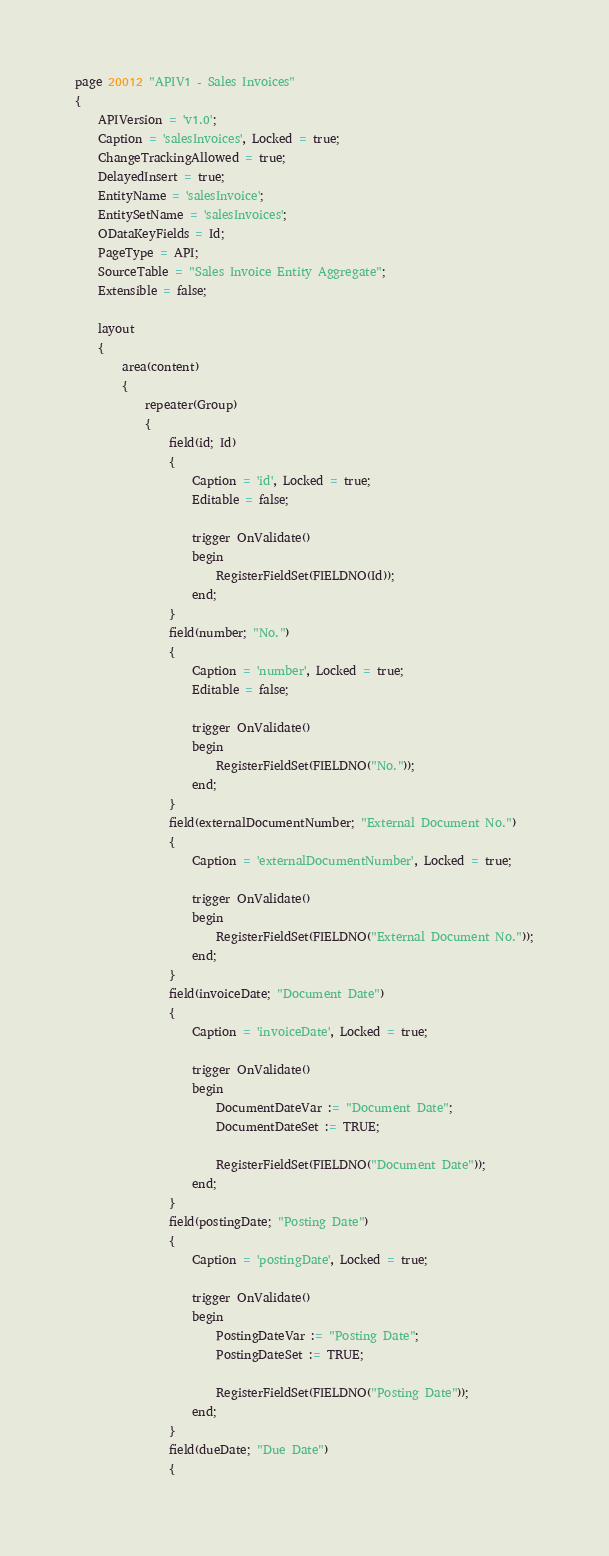<code> <loc_0><loc_0><loc_500><loc_500><_Perl_>page 20012 "APIV1 - Sales Invoices"
{
    APIVersion = 'v1.0';
    Caption = 'salesInvoices', Locked = true;
    ChangeTrackingAllowed = true;
    DelayedInsert = true;
    EntityName = 'salesInvoice';
    EntitySetName = 'salesInvoices';
    ODataKeyFields = Id;
    PageType = API;
    SourceTable = "Sales Invoice Entity Aggregate";
    Extensible = false;

    layout
    {
        area(content)
        {
            repeater(Group)
            {
                field(id; Id)
                {
                    Caption = 'id', Locked = true;
                    Editable = false;

                    trigger OnValidate()
                    begin
                        RegisterFieldSet(FIELDNO(Id));
                    end;
                }
                field(number; "No.")
                {
                    Caption = 'number', Locked = true;
                    Editable = false;

                    trigger OnValidate()
                    begin
                        RegisterFieldSet(FIELDNO("No."));
                    end;
                }
                field(externalDocumentNumber; "External Document No.")
                {
                    Caption = 'externalDocumentNumber', Locked = true;

                    trigger OnValidate()
                    begin
                        RegisterFieldSet(FIELDNO("External Document No."));
                    end;
                }
                field(invoiceDate; "Document Date")
                {
                    Caption = 'invoiceDate', Locked = true;

                    trigger OnValidate()
                    begin
                        DocumentDateVar := "Document Date";
                        DocumentDateSet := TRUE;

                        RegisterFieldSet(FIELDNO("Document Date"));
                    end;
                }
                field(postingDate; "Posting Date")
                {
                    Caption = 'postingDate', Locked = true;

                    trigger OnValidate()
                    begin
                        PostingDateVar := "Posting Date";
                        PostingDateSet := TRUE;

                        RegisterFieldSet(FIELDNO("Posting Date"));
                    end;
                }
                field(dueDate; "Due Date")
                {</code> 